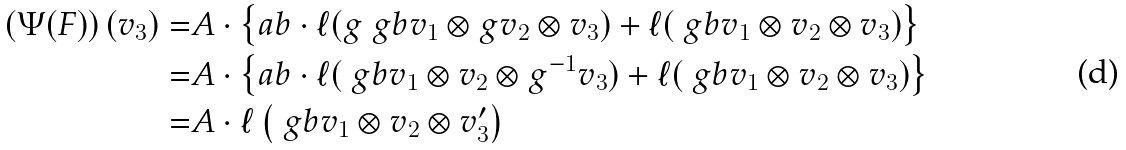Convert formula to latex. <formula><loc_0><loc_0><loc_500><loc_500>\left ( \Psi ( F ) \right ) ( v _ { 3 } ) = & A \cdot \left \{ a b \cdot \ell ( g \ g b v _ { 1 } \otimes g v _ { 2 } \otimes v _ { 3 } ) + \ell ( \ g b v _ { 1 } \otimes v _ { 2 } \otimes v _ { 3 } ) \right \} \\ = & A \cdot \left \{ a b \cdot \ell ( \ g b v _ { 1 } \otimes v _ { 2 } \otimes g ^ { - 1 } v _ { 3 } ) + \ell ( \ g b v _ { 1 } \otimes v _ { 2 } \otimes v _ { 3 } ) \right \} \\ = & A \cdot \ell \left ( \ g b v _ { 1 } \otimes v _ { 2 } \otimes v _ { 3 } ^ { \prime } \right ) \\</formula> 